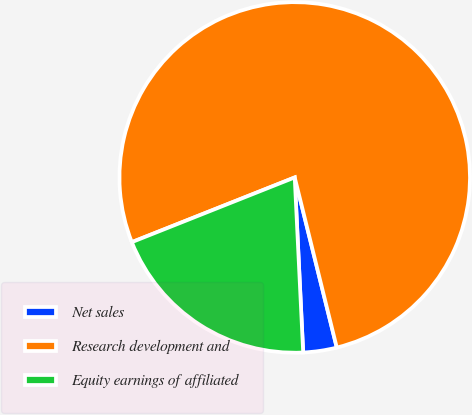<chart> <loc_0><loc_0><loc_500><loc_500><pie_chart><fcel>Net sales<fcel>Research development and<fcel>Equity earnings of affiliated<nl><fcel>3.09%<fcel>77.16%<fcel>19.75%<nl></chart> 